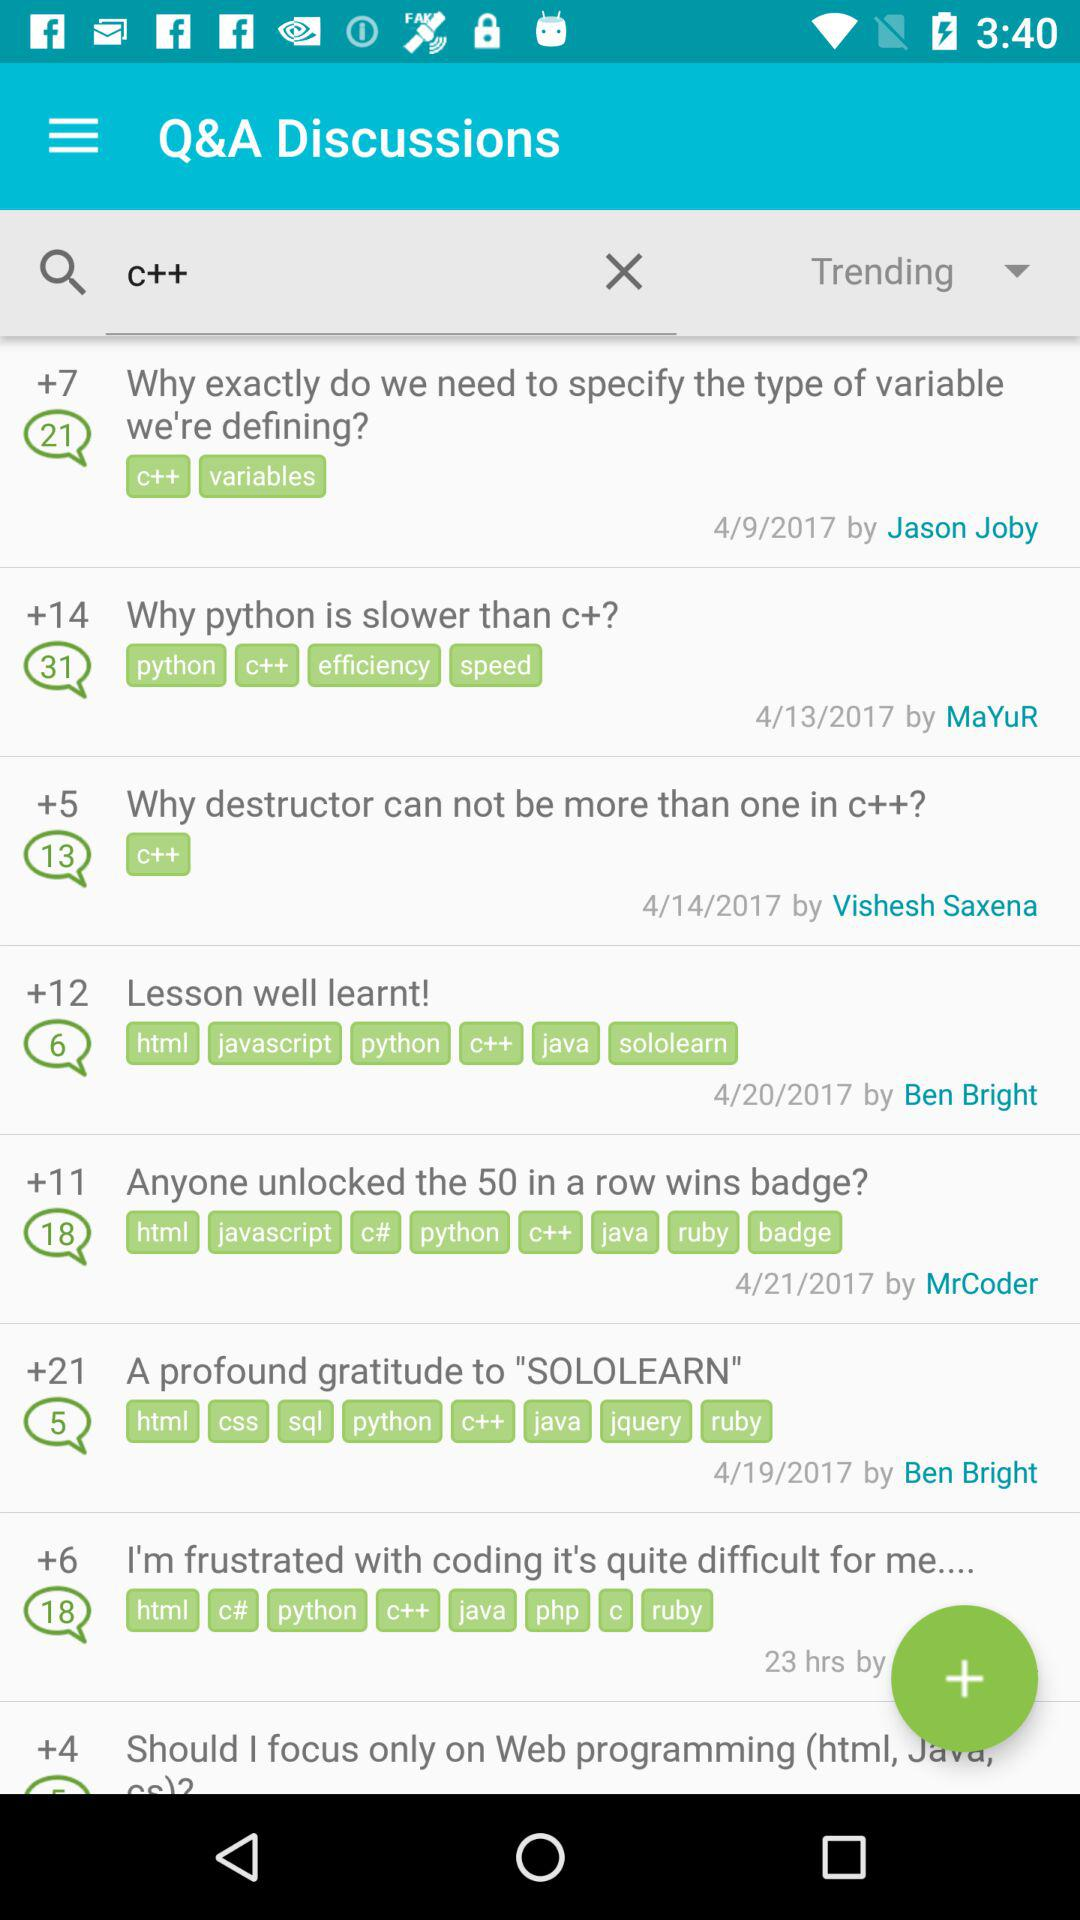How many comments are shown on the lesson well learnt? There are 6 comments on the lesson well learnt. 